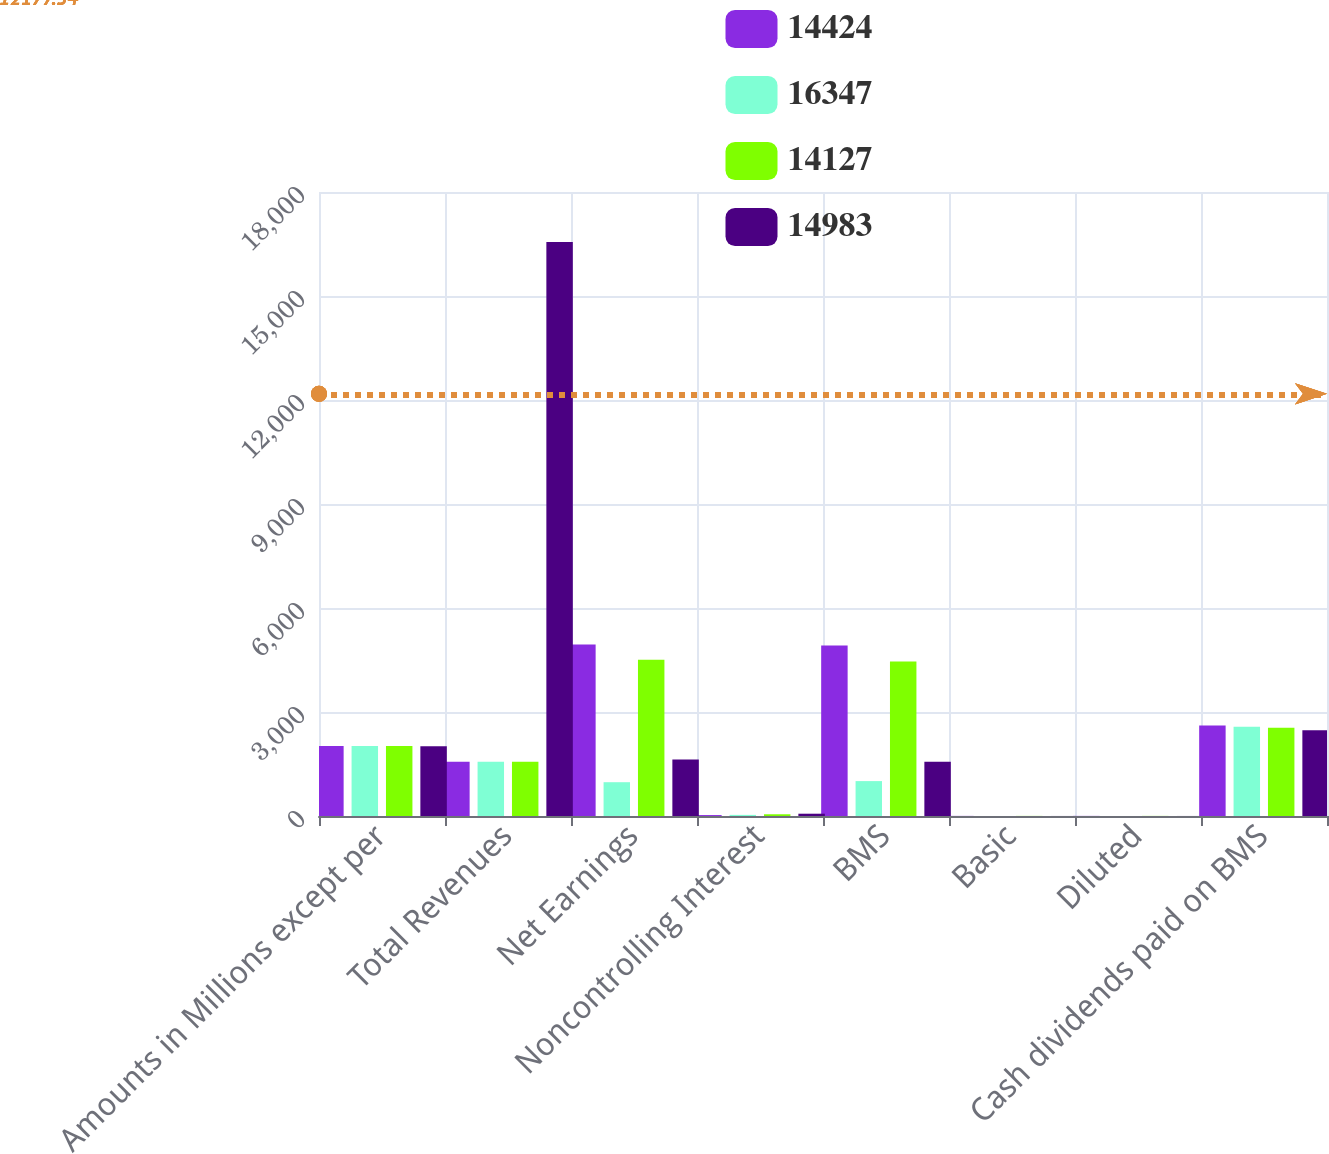<chart> <loc_0><loc_0><loc_500><loc_500><stacked_bar_chart><ecel><fcel>Amounts in Millions except per<fcel>Total Revenues<fcel>Net Earnings<fcel>Noncontrolling Interest<fcel>BMS<fcel>Basic<fcel>Diluted<fcel>Cash dividends paid on BMS<nl><fcel>14424<fcel>2018<fcel>1565<fcel>4947<fcel>27<fcel>4920<fcel>3.01<fcel>3.01<fcel>2613<nl><fcel>16347<fcel>2017<fcel>1565<fcel>975<fcel>32<fcel>1007<fcel>0.61<fcel>0.61<fcel>2577<nl><fcel>14127<fcel>2016<fcel>1565<fcel>4507<fcel>50<fcel>4457<fcel>2.67<fcel>2.65<fcel>2547<nl><fcel>14983<fcel>2015<fcel>16560<fcel>1631<fcel>66<fcel>1565<fcel>0.94<fcel>0.93<fcel>2477<nl></chart> 